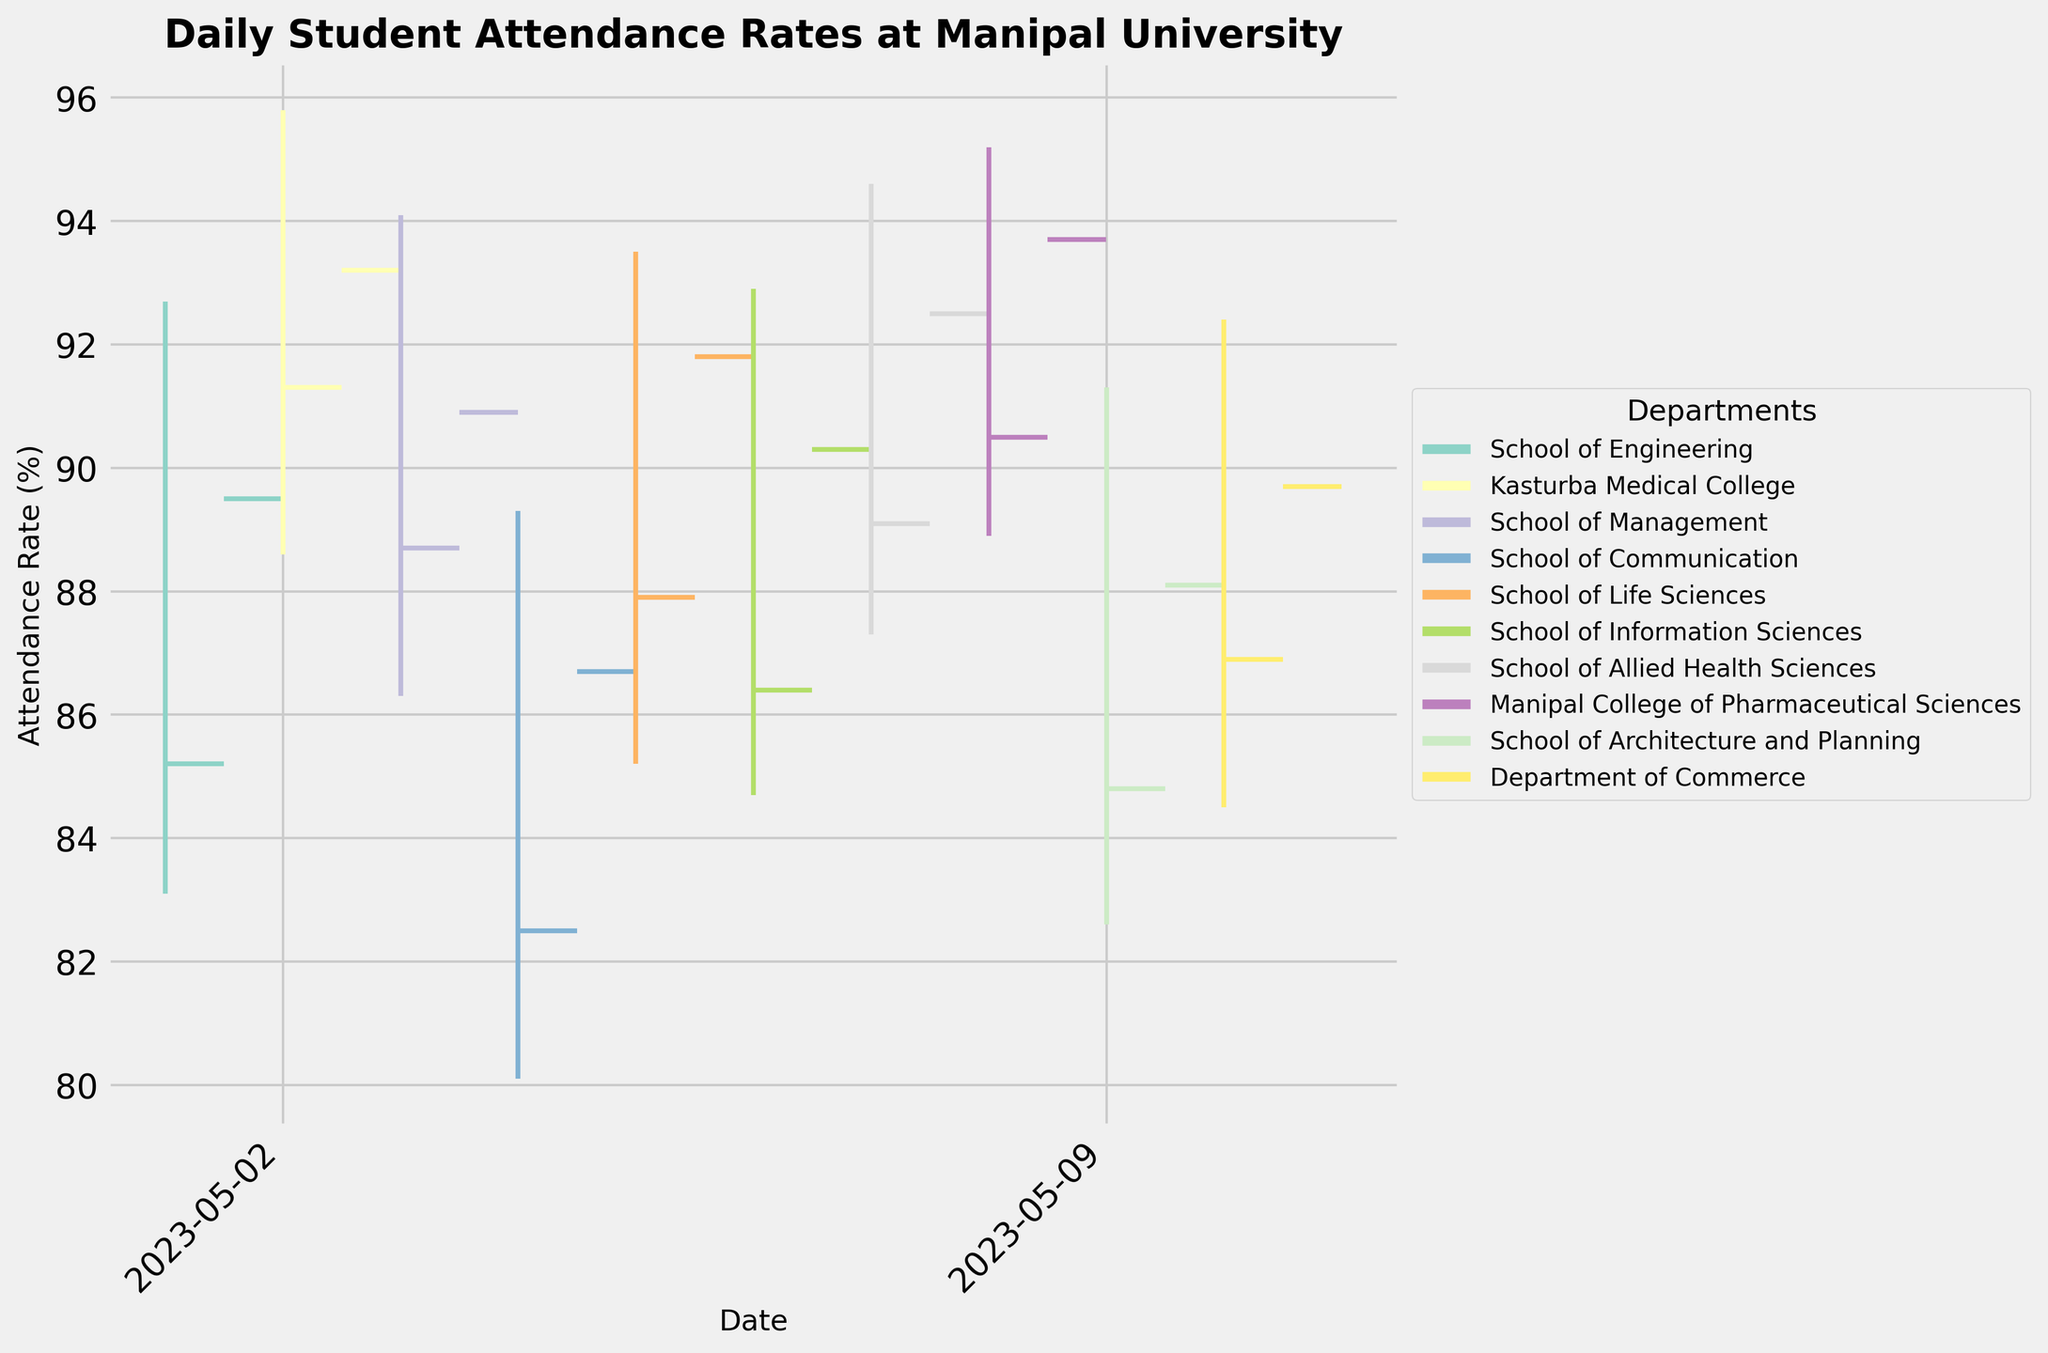Which department had the highest student attendance rate on May 8, 2023? The plot indicates that each department is represented with a distinct color. By observing the highest point on May 8, 2023, we can see that the highest rate lies at 95.2%, which falls under Manipal College of Pharmaceutical Sciences.
Answer: Manipal College of Pharmaceutical Sciences How does the average daily attendance rate of the School of Communication compare to that of the School of Management? We need to look at the high, low, opening, and closing attendance rates for both departments. The rates for the School of Communication are 82.5, 89.3, 80.1, and 86.7, respectively. For the School of Management, they are 88.7, 94.1, 86.3, and 90.9. Calculating the averages: (82.5+89.3+80.1+86.7)/4 = 84.65 for Communication and (88.7+94.1+86.3+90.9)/4 = 89.75 for Management. The average for Management is higher.
Answer: School of Management Which department had the smallest range of attendance rates on May 9, 2023? The range of attendance rates is the difference between the high and low values. For May 9th, we see High = 91.3 and Low = 82.6 for the School of Architecture and Planning, so the range is 91.3 - 82.6 = 8.7%.
Answer: School of Architecture and Planning Did any department's attendance rate close lower than its open rate on May 6, 2023? We need to compare the opening and closing rates for May 6th. For the School of Information Sciences, they opened at 86.4% and closed at 90.3%, closing higher than it opened. Therefore, no department’s attendance rate closed lower than its open rate on this day.
Answer: No What was the highest attendance rate recorded across all departments during the period shown? Inspecting the axes and individual points on the plot, the highest attendance rate recorded is 95.8% by Kasturba Medical College on May 2, 2023.
Answer: 95.8% Which department experienced the highest volatility in attendance rate on May 10, 2023? Volatility can be assessed by examining the range between the high and low values. For May 10, we have the Department of Commerce with High = 92.4 and Low = 84.5, so the range is 92.4 - 84.5 = 7.9%. Check the plot to confirm this is the highest range for the given date.
Answer: Department of Commerce Calculate the average closing attendance rate of all departments shown. Sum all closing attendance rates and divide by the number of departments. Closing rates: 89.5, 93.2, 90.9, 86.7, 91.8, 90.3, 92.5, 93.7, 88.1, 89.7. The total is 906.4. There are 10 departments, so average = 906.4 / 10 = 90.64%.
Answer: 90.64% Which department's attendance rate had the largest drop from high to low on May 4, 2023? By looking at the high and low rates of May 4th, the School of Communication had highs of 89.3% and lows of 80.1%, which is a drop of 89.3 - 80.1 = 9.2%. This is the largest drop observed on that day.
Answer: School of Communication 